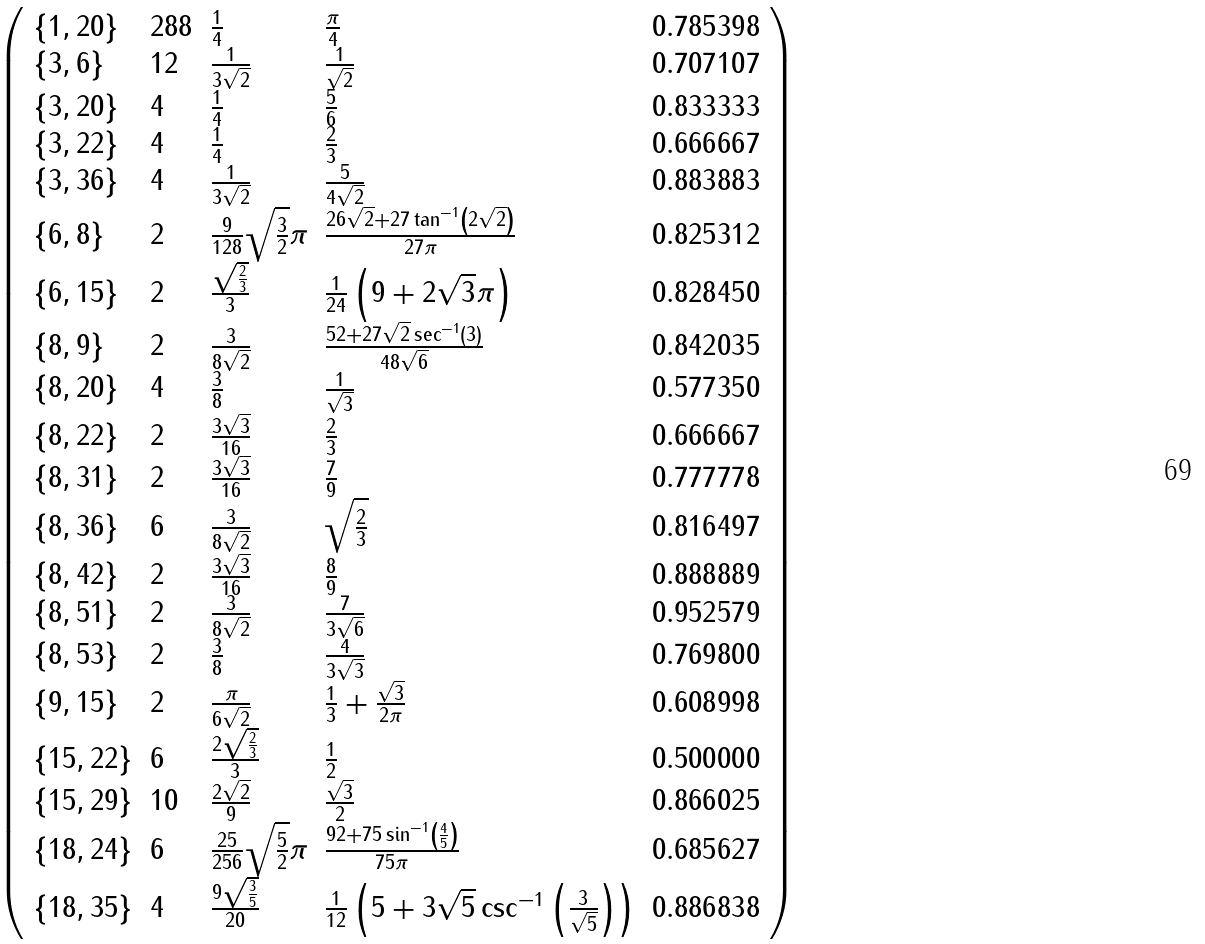<formula> <loc_0><loc_0><loc_500><loc_500>\left ( \begin{array} { l l l l l } \{ 1 , 2 0 \} & 2 8 8 & \frac { 1 } { 4 } & \frac { \pi } { 4 } & 0 . 7 8 5 3 9 8 \\ \{ 3 , 6 \} & 1 2 & \frac { 1 } { 3 \sqrt { 2 } } & \frac { 1 } { \sqrt { 2 } } & 0 . 7 0 7 1 0 7 \\ \{ 3 , 2 0 \} & 4 & \frac { 1 } { 4 } & \frac { 5 } { 6 } & 0 . 8 3 3 3 3 3 \\ \{ 3 , 2 2 \} & 4 & \frac { 1 } { 4 } & \frac { 2 } { 3 } & 0 . 6 6 6 6 6 7 \\ \{ 3 , 3 6 \} & 4 & \frac { 1 } { 3 \sqrt { 2 } } & \frac { 5 } { 4 \sqrt { 2 } } & 0 . 8 8 3 8 8 3 \\ \{ 6 , 8 \} & 2 & \frac { 9 } { 1 2 8 } \sqrt { \frac { 3 } { 2 } } \pi & \frac { 2 6 \sqrt { 2 } + 2 7 \tan ^ { - 1 } \left ( 2 \sqrt { 2 } \right ) } { 2 7 \pi } & 0 . 8 2 5 3 1 2 \\ \{ 6 , 1 5 \} & 2 & \frac { \sqrt { \frac { 2 } { 3 } } } { 3 } & \frac { 1 } { 2 4 } \left ( 9 + 2 \sqrt { 3 } \pi \right ) & 0 . 8 2 8 4 5 0 \\ \{ 8 , 9 \} & 2 & \frac { 3 } { 8 \sqrt { 2 } } & \frac { 5 2 + 2 7 \sqrt { 2 } \sec ^ { - 1 } ( 3 ) } { 4 8 \sqrt { 6 } } & 0 . 8 4 2 0 3 5 \\ \{ 8 , 2 0 \} & 4 & \frac { 3 } { 8 } & \frac { 1 } { \sqrt { 3 } } & 0 . 5 7 7 3 5 0 \\ \{ 8 , 2 2 \} & 2 & \frac { 3 \sqrt { 3 } } { 1 6 } & \frac { 2 } { 3 } & 0 . 6 6 6 6 6 7 \\ \{ 8 , 3 1 \} & 2 & \frac { 3 \sqrt { 3 } } { 1 6 } & \frac { 7 } { 9 } & 0 . 7 7 7 7 7 8 \\ \{ 8 , 3 6 \} & 6 & \frac { 3 } { 8 \sqrt { 2 } } & \sqrt { \frac { 2 } { 3 } } & 0 . 8 1 6 4 9 7 \\ \{ 8 , 4 2 \} & 2 & \frac { 3 \sqrt { 3 } } { 1 6 } & \frac { 8 } { 9 } & 0 . 8 8 8 8 8 9 \\ \{ 8 , 5 1 \} & 2 & \frac { 3 } { 8 \sqrt { 2 } } & \frac { 7 } { 3 \sqrt { 6 } } & 0 . 9 5 2 5 7 9 \\ \{ 8 , 5 3 \} & 2 & \frac { 3 } { 8 } & \frac { 4 } { 3 \sqrt { 3 } } & 0 . 7 6 9 8 0 0 \\ \{ 9 , 1 5 \} & 2 & \frac { \pi } { 6 \sqrt { 2 } } & \frac { 1 } { 3 } + \frac { \sqrt { 3 } } { 2 \pi } & 0 . 6 0 8 9 9 8 \\ \{ 1 5 , 2 2 \} & 6 & \frac { 2 \sqrt { \frac { 2 } { 3 } } } { 3 } & \frac { 1 } { 2 } & 0 . 5 0 0 0 0 0 \\ \{ 1 5 , 2 9 \} & 1 0 & \frac { 2 \sqrt { 2 } } { 9 } & \frac { \sqrt { 3 } } { 2 } & 0 . 8 6 6 0 2 5 \\ \{ 1 8 , 2 4 \} & 6 & \frac { 2 5 } { 2 5 6 } \sqrt { \frac { 5 } { 2 } } \pi & \frac { 9 2 + 7 5 \sin ^ { - 1 } \left ( \frac { 4 } { 5 } \right ) } { 7 5 \pi } & 0 . 6 8 5 6 2 7 \\ \{ 1 8 , 3 5 \} & 4 & \frac { 9 \sqrt { \frac { 3 } { 5 } } } { 2 0 } & \frac { 1 } { 1 2 } \left ( 5 + 3 \sqrt { 5 } \csc ^ { - 1 } \left ( \frac { 3 } { \sqrt { 5 } } \right ) \right ) & 0 . 8 8 6 8 3 8 \end{array} \right )</formula> 